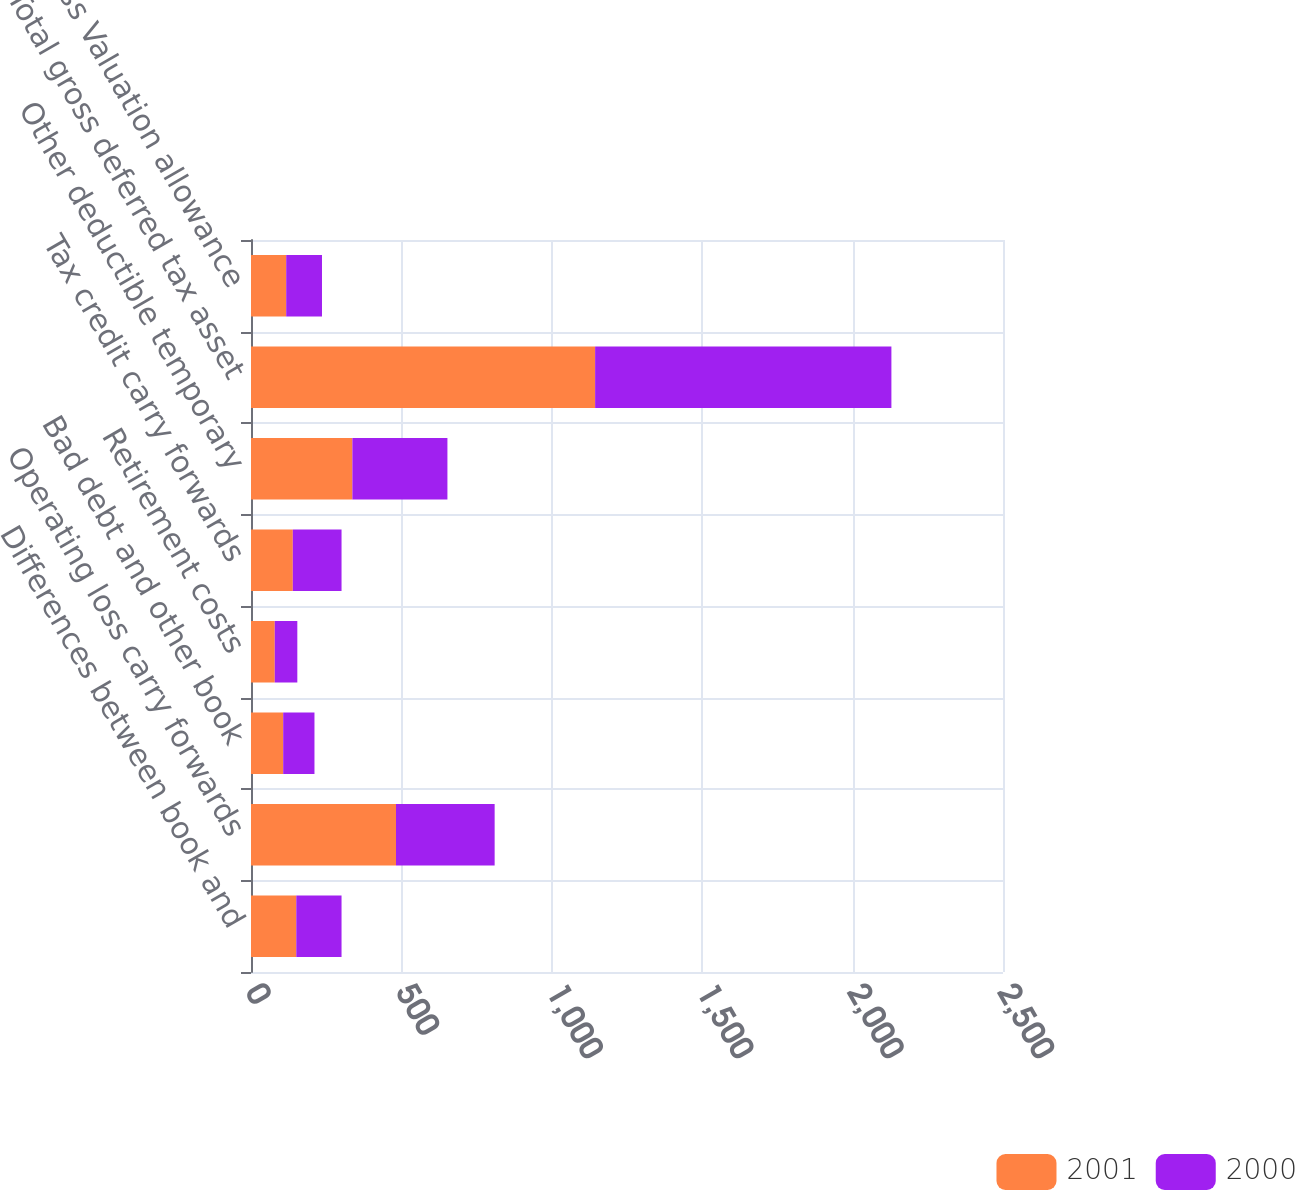<chart> <loc_0><loc_0><loc_500><loc_500><stacked_bar_chart><ecel><fcel>Differences between book and<fcel>Operating loss carry forwards<fcel>Bad debt and other book<fcel>Retirement costs<fcel>Tax credit carry forwards<fcel>Other deductible temporary<fcel>Total gross deferred tax asset<fcel>Less Valuation allowance<nl><fcel>2001<fcel>150.5<fcel>482<fcel>107<fcel>79<fcel>139<fcel>337<fcel>1144<fcel>117<nl><fcel>2000<fcel>150.5<fcel>328<fcel>104<fcel>75<fcel>162<fcel>316<fcel>985<fcel>119<nl></chart> 